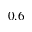Convert formula to latex. <formula><loc_0><loc_0><loc_500><loc_500>0 . 6</formula> 